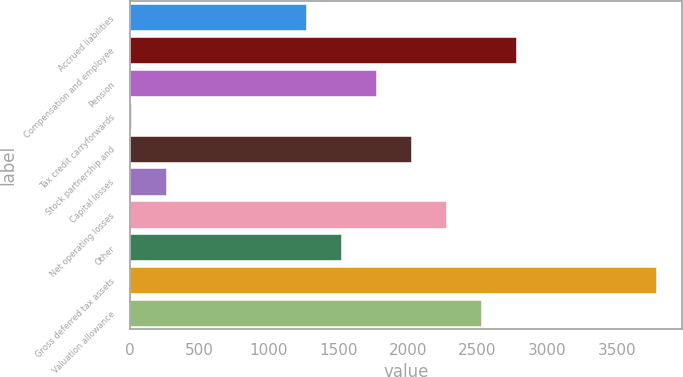<chart> <loc_0><loc_0><loc_500><loc_500><bar_chart><fcel>Accrued liabilities<fcel>Compensation and employee<fcel>Pension<fcel>Tax credit carryforwards<fcel>Stock partnership and<fcel>Capital losses<fcel>Net operating losses<fcel>Other<fcel>Gross deferred tax assets<fcel>Valuation allowance<nl><fcel>1266<fcel>2776.32<fcel>1769.44<fcel>7.4<fcel>2021.16<fcel>259.12<fcel>2272.88<fcel>1517.72<fcel>3783.2<fcel>2524.6<nl></chart> 